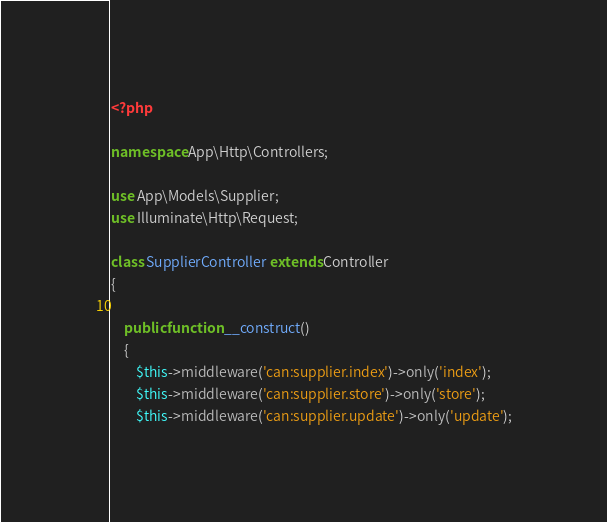<code> <loc_0><loc_0><loc_500><loc_500><_PHP_><?php

namespace App\Http\Controllers;

use App\Models\Supplier;
use Illuminate\Http\Request;

class SupplierController extends Controller
{

	public function __construct()
	{
		$this->middleware('can:supplier.index')->only('index');
		$this->middleware('can:supplier.store')->only('store');
		$this->middleware('can:supplier.update')->only('update');</code> 